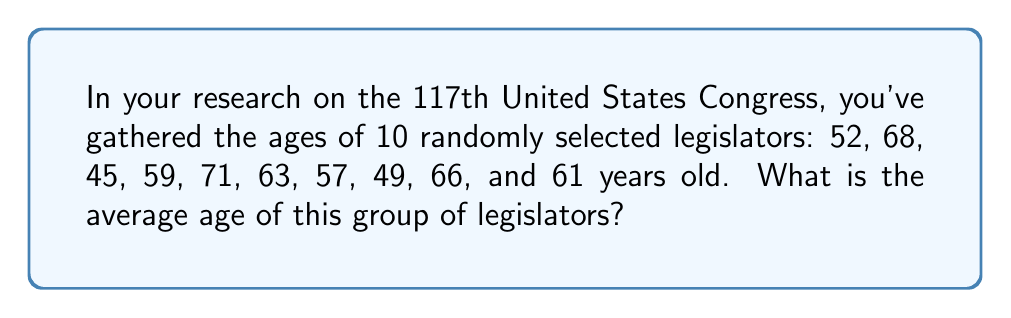Could you help me with this problem? To find the average age of the legislators, we need to follow these steps:

1. Sum up all the ages:
   $52 + 68 + 45 + 59 + 71 + 63 + 57 + 49 + 66 + 61 = 591$

2. Count the total number of legislators:
   There are 10 legislators in this sample.

3. Calculate the average by dividing the sum by the total number:
   $$\text{Average} = \frac{\text{Sum of ages}}{\text{Number of legislators}} = \frac{591}{10} = 59.1$$

Therefore, the average age of this group of legislators is 59.1 years old.
Answer: 59.1 years 